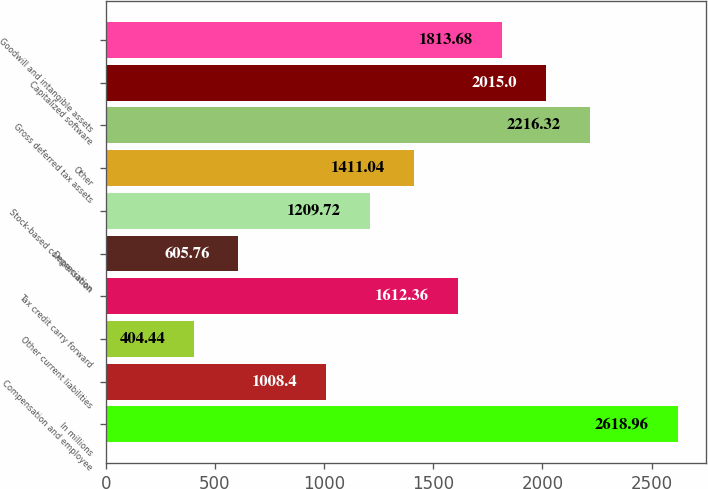Convert chart to OTSL. <chart><loc_0><loc_0><loc_500><loc_500><bar_chart><fcel>In millions<fcel>Compensation and employee<fcel>Other current liabilities<fcel>Tax credit carry forward<fcel>Depreciation<fcel>Stock-based compensation<fcel>Other<fcel>Gross deferred tax assets<fcel>Capitalized software<fcel>Goodwill and intangible assets<nl><fcel>2618.96<fcel>1008.4<fcel>404.44<fcel>1612.36<fcel>605.76<fcel>1209.72<fcel>1411.04<fcel>2216.32<fcel>2015<fcel>1813.68<nl></chart> 